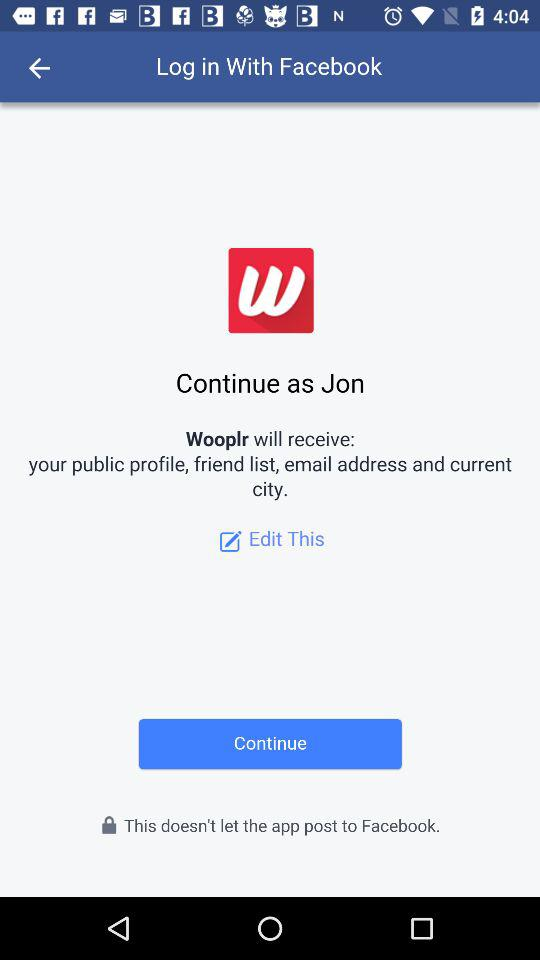What application will receive the public profile, friend list, email address and current city? The application that will receive the public profile, friend list, email address and current city is "Wooplr". 